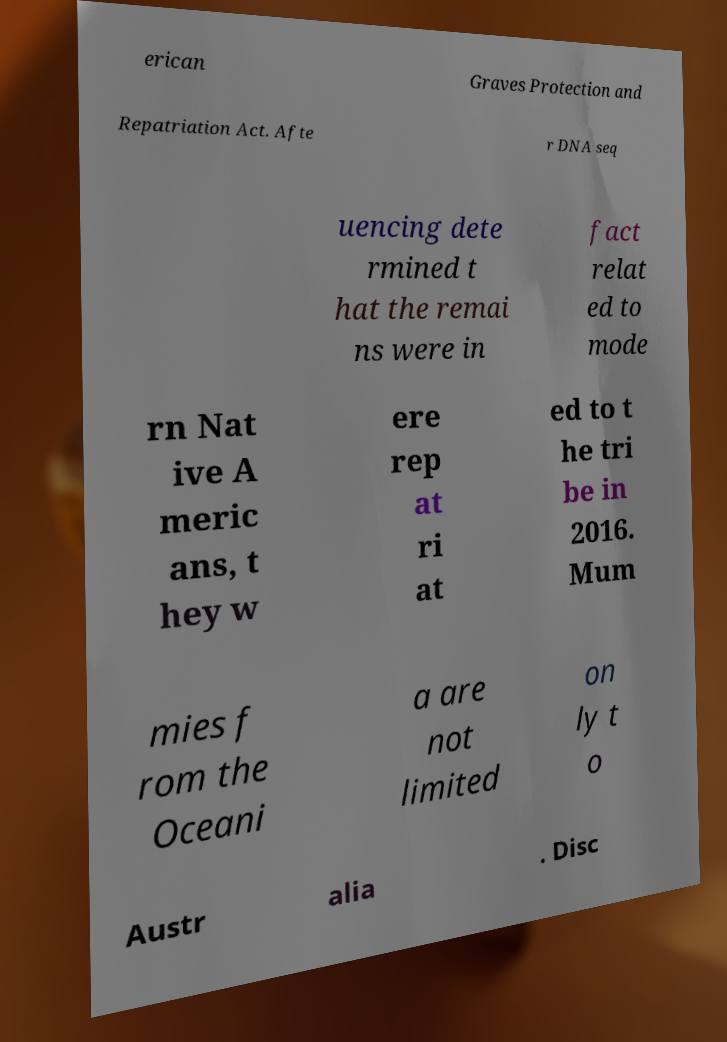Could you assist in decoding the text presented in this image and type it out clearly? erican Graves Protection and Repatriation Act. Afte r DNA seq uencing dete rmined t hat the remai ns were in fact relat ed to mode rn Nat ive A meric ans, t hey w ere rep at ri at ed to t he tri be in 2016. Mum mies f rom the Oceani a are not limited on ly t o Austr alia . Disc 